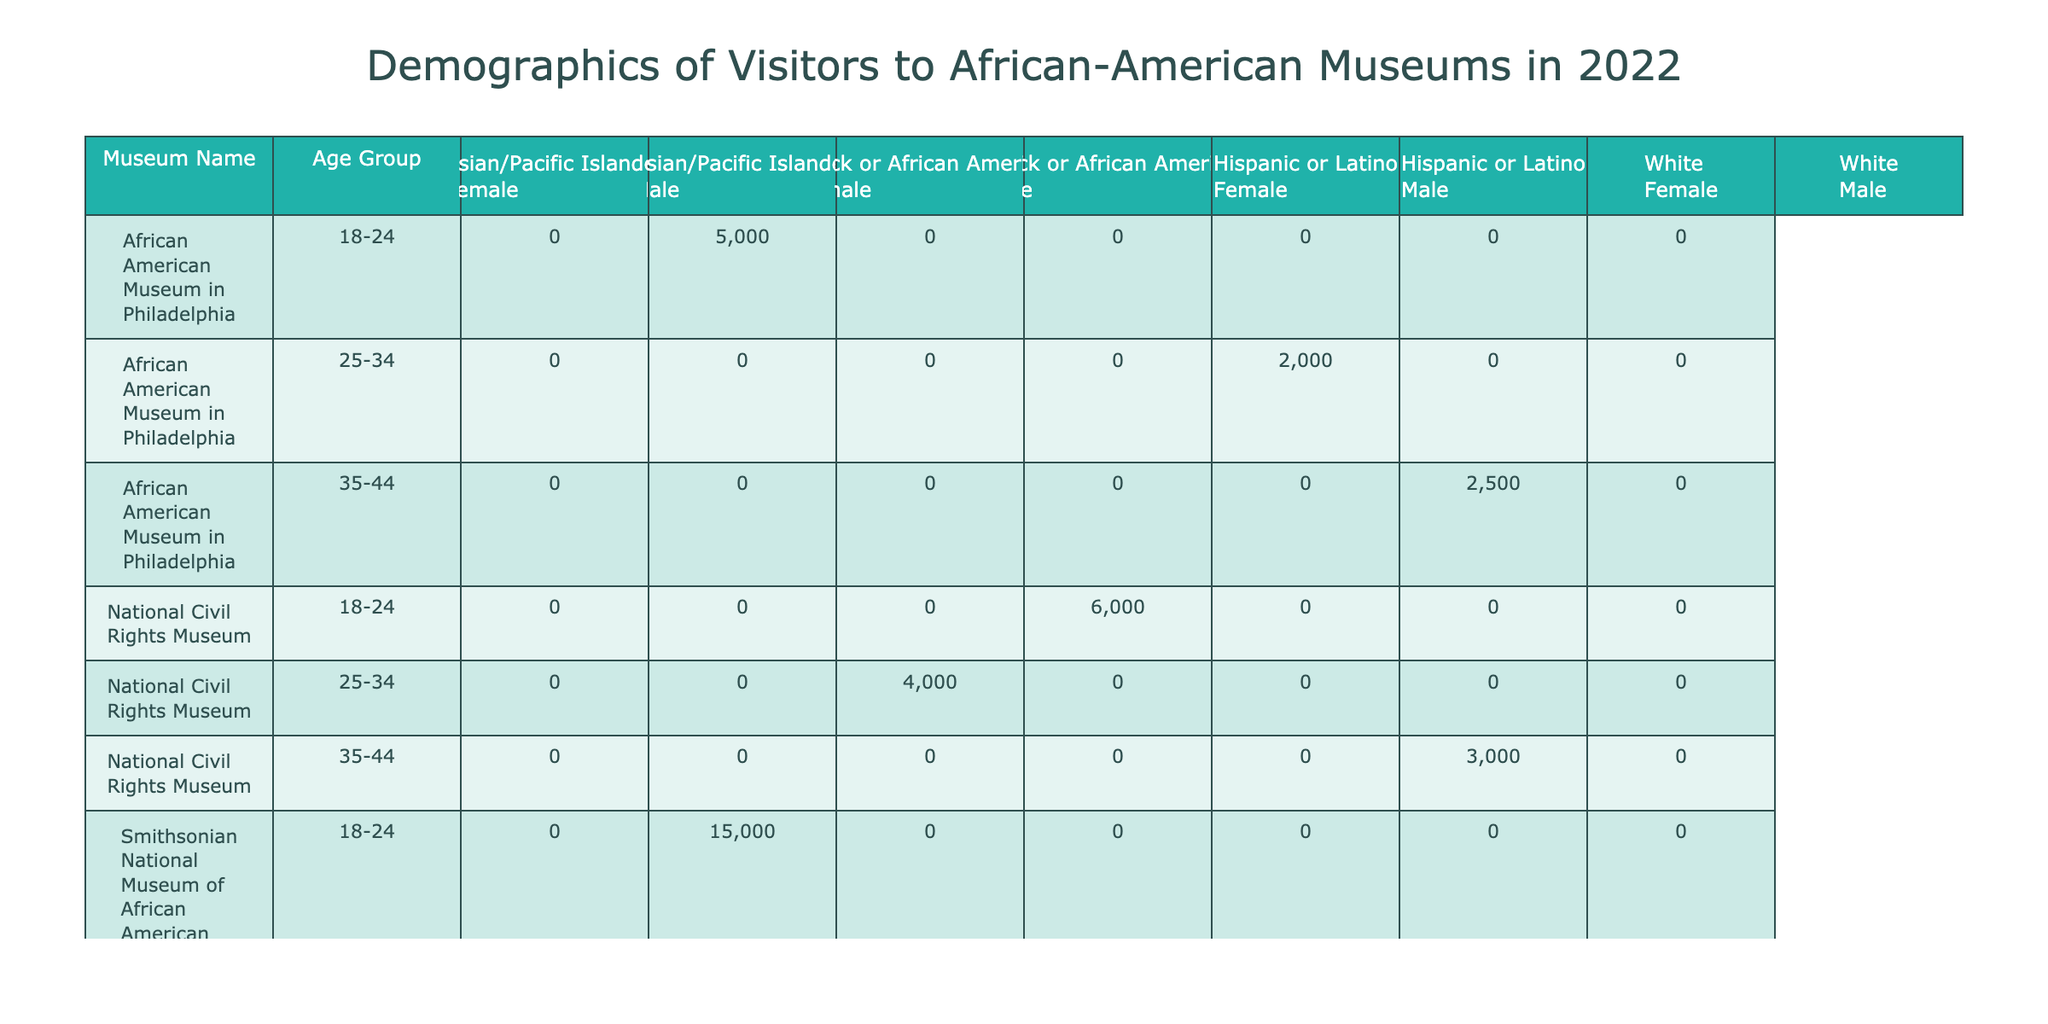What is the total attendance count for the Smithsonian National Museum of African American History and Culture? The table shows the attendance counts for different age groups at the Smithsonian National Museum of African American History and Culture. By summing the counts, we have 15000 for ages 18-24 and 10000 for ages 35-44. The count for ages 25-34 is 8000. Adding these gives us 15000 + 8000 + 10000 = 33000.
Answer: 33000 Which age group had the highest attendance at the National Civil Rights Museum? At the National Civil Rights Museum, the attendance counts by age group are: 6000 for 18-24, 4000 for 25-34, and 3000 for 35-44. Comparing these, the highest is 6000 for the 18-24 age group.
Answer: 18-24 Is there a male visitor from the 45-54 age group at The Charles H. Wright Museum of African American History? The table indicates that there is 3500 attendance in the 45-54 age group for the male ethnicity. This confirms that there are indeed male visitors from this age group at the museum.
Answer: Yes What is the total attendance for Black or African American visitors aged 25-34 across all museums? To find this, we will look at the counts for Black or African American visitors aged 25-34 across each museum: National Civil Rights Museum has 4000, and there’s no data from the other museums for this age group. Therefore, the total is 4000.
Answer: 4000 For which visitor gender does the African American Museum in Philadelphia have the highest attendance count in the age group of 18-24? The table reveals that in the 18-24 age group at the African American Museum in Philadelphia, there are 5000 female visitors and no specified count for male visitors. Therefore, the highest attendance is for female visitors in this age group.
Answer: Female 